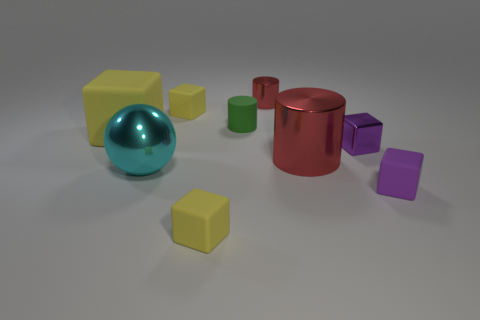How big is the metal thing that is both right of the small red metal cylinder and on the left side of the tiny purple metallic cube?
Offer a very short reply. Large. Is there a block behind the purple cube that is behind the big cyan object?
Make the answer very short. Yes. There is a tiny red cylinder; what number of large yellow cubes are left of it?
Your answer should be compact. 1. What is the color of the other metal object that is the same shape as the large red metallic thing?
Your answer should be very brief. Red. Are the small yellow block in front of the large yellow block and the yellow block behind the large cube made of the same material?
Offer a very short reply. Yes. There is a large cylinder; is it the same color as the matte object on the right side of the tiny red metallic cylinder?
Keep it short and to the point. No. The yellow object that is behind the metal block and right of the cyan sphere has what shape?
Make the answer very short. Cube. What number of tiny rubber things are there?
Ensure brevity in your answer.  4. The rubber thing that is the same color as the metal cube is what shape?
Provide a succinct answer. Cube. What size is the other purple object that is the same shape as the small purple shiny object?
Keep it short and to the point. Small. 